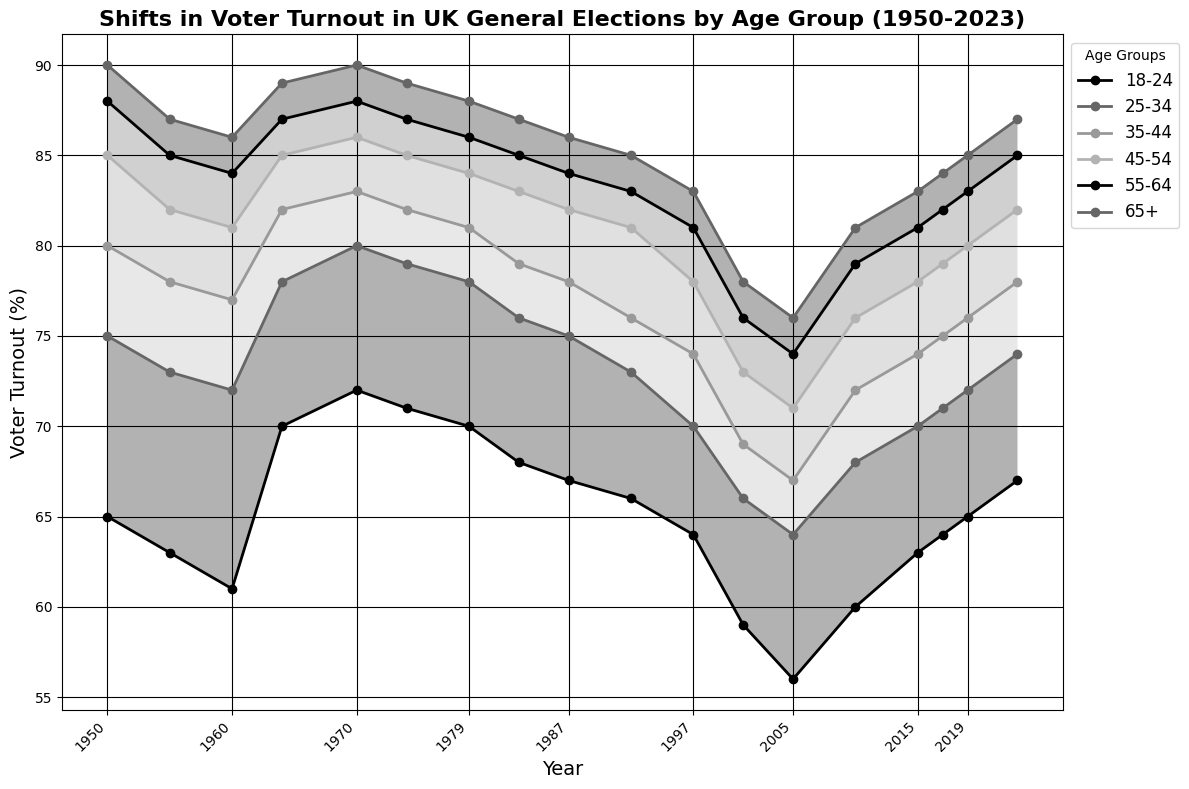Which age group had the highest voter turnout in 1950? Look at the line chart for the year 1950 and identify the age group with the highest value. The 65+ age group shows the highest turnout.
Answer: 65+ Which age group saw the most significant decline in voter turnout from 1950 to 2001? Compare the turnout percentages for each age group between 1950 and 2001. The 18-24 age group declined from 65% to 59%, a significant drop.
Answer: 18-24 What is the difference in voter turnout between the 18-24 and the 65+ age groups in 2023? Find the voter turnout percentages for both age groups in 2023 and subtract the 18-24 value from the 65+ value. The difference is 87% - 67% = 20%.
Answer: 20% Which age group had the closest voter turnout percentage in 1987 to the 25-34 age group's voter turnout in 1979? Compare the voter turnout of the 25-34 age group in 1979 (78%) with other age groups’ turnouts in 1987. The 18-24 age group in 1987 has a turnout close to 78%.
Answer: 18-24 How did the voter turnout change for the 45-54 age group from 1997 to 2019? Look at the voter turnout percentage for the 45-54 age group in both 1997 (78%) and 2019 (80%). The change is 80% - 78% = 2% increase.
Answer: Increased by 2% Which age group consistently had higher voter turnout than the 18-24 age group throughout the years? Examine the lines for each age group compared to the 18-24 group. The 55-64 and 65+ age groups consistently had higher turnout than the 18-24 age group in all years.
Answer: 55-64 and 65+ What was the trend of voter turnout for the 35-44 age group from 2001 to 2010? Look at the voter turnout values for the 35-44 age group in 2001 (69%), 2005 (67%), and 2010 (72%). The trend shows a decrease from 69% to 67% and then an increase to 72%.
Answer: Decrease and then increase Which election year marked a significant dip in voter turnout across all age groups? Identify the year on the chart where a noticeable dip occurred for all lines. The year 2001 shows a visible dip for all age groups.
Answer: 2001 